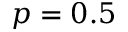<formula> <loc_0><loc_0><loc_500><loc_500>p = 0 . 5</formula> 